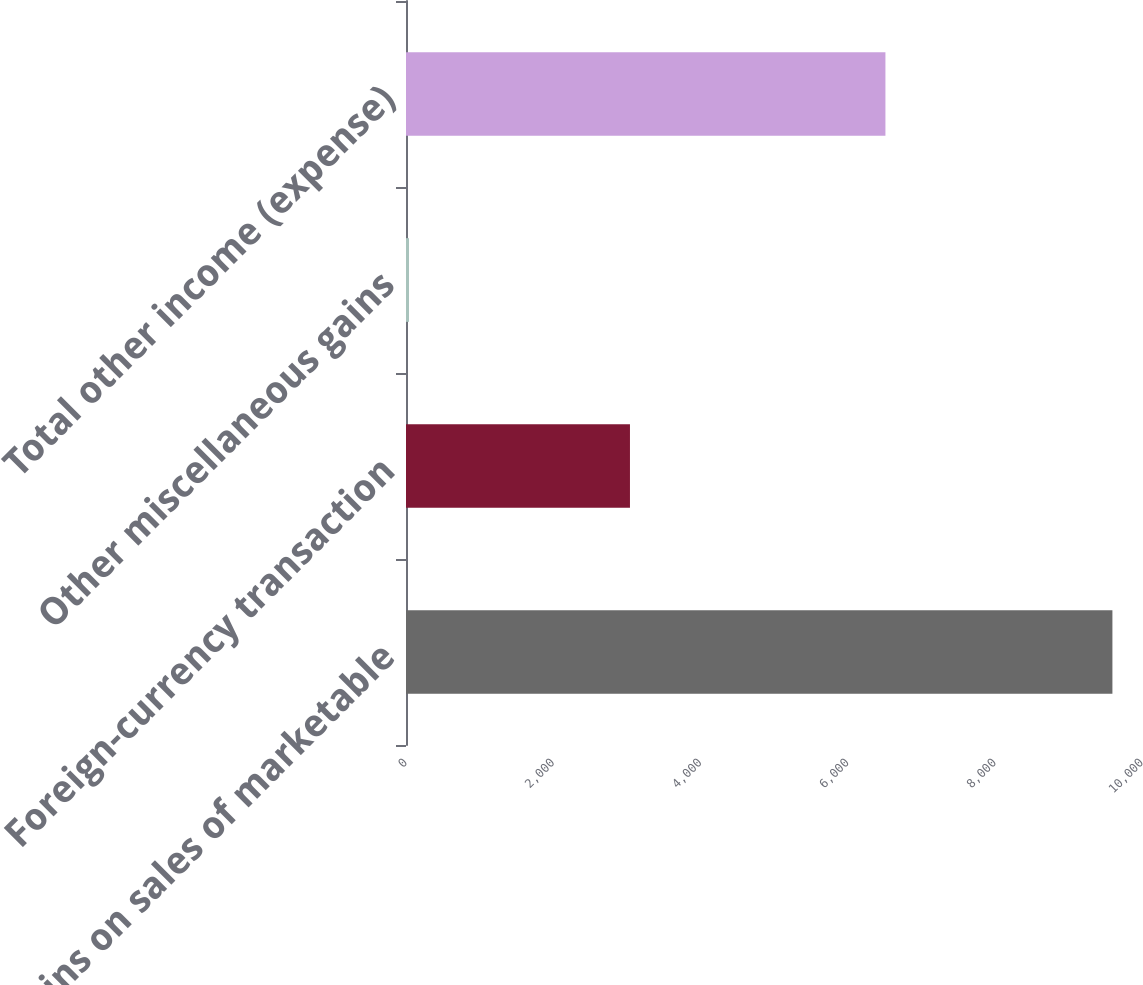Convert chart to OTSL. <chart><loc_0><loc_0><loc_500><loc_500><bar_chart><fcel>Gains on sales of marketable<fcel>Foreign-currency transaction<fcel>Other miscellaneous gains<fcel>Total other income (expense)<nl><fcel>9598<fcel>3043<fcel>41<fcel>6514<nl></chart> 